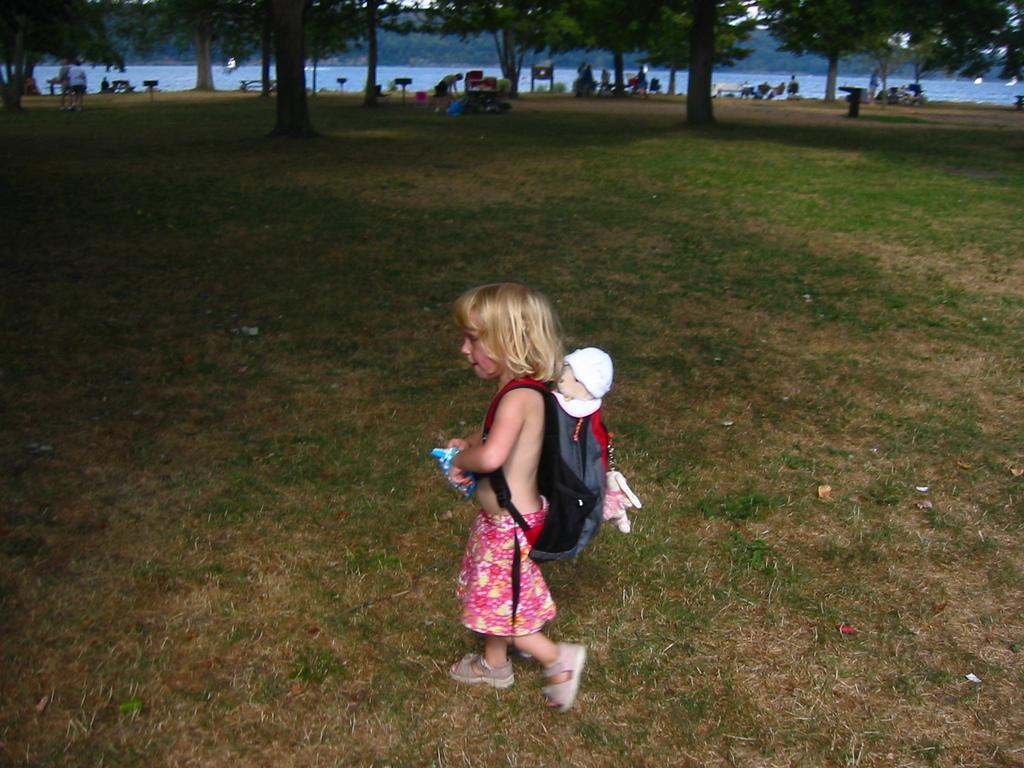Please provide a concise description of this image. There is a small girl in the center of the image she is wearing a bag and there is a toy on the bag, on the grassland, by holding a snack packet in her hands. There are people, benches, water, trees, it seems like sign boards and the sky in the background area. 